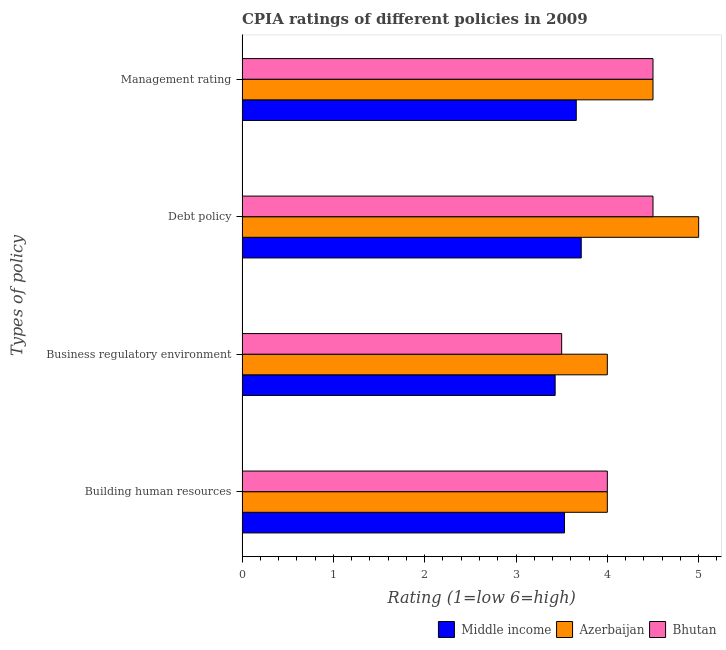How many groups of bars are there?
Give a very brief answer. 4. Are the number of bars on each tick of the Y-axis equal?
Offer a very short reply. Yes. How many bars are there on the 2nd tick from the bottom?
Provide a succinct answer. 3. What is the label of the 2nd group of bars from the top?
Provide a short and direct response. Debt policy. What is the cpia rating of management in Middle income?
Ensure brevity in your answer.  3.66. Across all countries, what is the minimum cpia rating of building human resources?
Make the answer very short. 3.53. In which country was the cpia rating of debt policy maximum?
Offer a terse response. Azerbaijan. In which country was the cpia rating of building human resources minimum?
Your answer should be very brief. Middle income. What is the total cpia rating of building human resources in the graph?
Offer a very short reply. 11.53. What is the difference between the cpia rating of debt policy in Bhutan and that in Azerbaijan?
Offer a terse response. -0.5. What is the difference between the cpia rating of management in Azerbaijan and the cpia rating of building human resources in Middle income?
Keep it short and to the point. 0.97. What is the average cpia rating of debt policy per country?
Provide a short and direct response. 4.4. What is the difference between the cpia rating of business regulatory environment and cpia rating of building human resources in Middle income?
Your answer should be compact. -0.1. What is the ratio of the cpia rating of debt policy in Bhutan to that in Middle income?
Give a very brief answer. 1.21. Is the cpia rating of debt policy in Middle income less than that in Azerbaijan?
Make the answer very short. Yes. What is the difference between the highest and the lowest cpia rating of debt policy?
Your answer should be compact. 1.29. In how many countries, is the cpia rating of management greater than the average cpia rating of management taken over all countries?
Your response must be concise. 2. Is the sum of the cpia rating of building human resources in Middle income and Azerbaijan greater than the maximum cpia rating of debt policy across all countries?
Make the answer very short. Yes. Is it the case that in every country, the sum of the cpia rating of building human resources and cpia rating of management is greater than the sum of cpia rating of debt policy and cpia rating of business regulatory environment?
Ensure brevity in your answer.  No. What does the 3rd bar from the bottom in Building human resources represents?
Keep it short and to the point. Bhutan. Is it the case that in every country, the sum of the cpia rating of building human resources and cpia rating of business regulatory environment is greater than the cpia rating of debt policy?
Your answer should be very brief. Yes. How many bars are there?
Offer a very short reply. 12. How many countries are there in the graph?
Provide a short and direct response. 3. What is the difference between two consecutive major ticks on the X-axis?
Give a very brief answer. 1. Are the values on the major ticks of X-axis written in scientific E-notation?
Your response must be concise. No. Does the graph contain any zero values?
Your response must be concise. No. Does the graph contain grids?
Offer a terse response. No. How are the legend labels stacked?
Your answer should be compact. Horizontal. What is the title of the graph?
Provide a succinct answer. CPIA ratings of different policies in 2009. Does "Oman" appear as one of the legend labels in the graph?
Provide a succinct answer. No. What is the label or title of the Y-axis?
Ensure brevity in your answer.  Types of policy. What is the Rating (1=low 6=high) in Middle income in Building human resources?
Provide a short and direct response. 3.53. What is the Rating (1=low 6=high) of Bhutan in Building human resources?
Ensure brevity in your answer.  4. What is the Rating (1=low 6=high) of Middle income in Business regulatory environment?
Keep it short and to the point. 3.43. What is the Rating (1=low 6=high) of Middle income in Debt policy?
Make the answer very short. 3.71. What is the Rating (1=low 6=high) in Azerbaijan in Debt policy?
Your answer should be very brief. 5. What is the Rating (1=low 6=high) in Bhutan in Debt policy?
Give a very brief answer. 4.5. What is the Rating (1=low 6=high) of Middle income in Management rating?
Make the answer very short. 3.66. What is the Rating (1=low 6=high) of Azerbaijan in Management rating?
Offer a very short reply. 4.5. Across all Types of policy, what is the maximum Rating (1=low 6=high) in Middle income?
Offer a very short reply. 3.71. Across all Types of policy, what is the maximum Rating (1=low 6=high) of Azerbaijan?
Make the answer very short. 5. Across all Types of policy, what is the minimum Rating (1=low 6=high) of Middle income?
Keep it short and to the point. 3.43. What is the total Rating (1=low 6=high) of Middle income in the graph?
Your response must be concise. 14.33. What is the total Rating (1=low 6=high) of Azerbaijan in the graph?
Make the answer very short. 17.5. What is the total Rating (1=low 6=high) in Bhutan in the graph?
Ensure brevity in your answer.  16.5. What is the difference between the Rating (1=low 6=high) of Middle income in Building human resources and that in Business regulatory environment?
Ensure brevity in your answer.  0.1. What is the difference between the Rating (1=low 6=high) in Bhutan in Building human resources and that in Business regulatory environment?
Your answer should be very brief. 0.5. What is the difference between the Rating (1=low 6=high) of Middle income in Building human resources and that in Debt policy?
Offer a terse response. -0.18. What is the difference between the Rating (1=low 6=high) in Azerbaijan in Building human resources and that in Debt policy?
Provide a succinct answer. -1. What is the difference between the Rating (1=low 6=high) in Bhutan in Building human resources and that in Debt policy?
Make the answer very short. -0.5. What is the difference between the Rating (1=low 6=high) of Middle income in Building human resources and that in Management rating?
Provide a short and direct response. -0.13. What is the difference between the Rating (1=low 6=high) in Middle income in Business regulatory environment and that in Debt policy?
Make the answer very short. -0.29. What is the difference between the Rating (1=low 6=high) of Azerbaijan in Business regulatory environment and that in Debt policy?
Keep it short and to the point. -1. What is the difference between the Rating (1=low 6=high) of Middle income in Business regulatory environment and that in Management rating?
Ensure brevity in your answer.  -0.23. What is the difference between the Rating (1=low 6=high) of Azerbaijan in Business regulatory environment and that in Management rating?
Keep it short and to the point. -0.5. What is the difference between the Rating (1=low 6=high) of Middle income in Debt policy and that in Management rating?
Your answer should be very brief. 0.05. What is the difference between the Rating (1=low 6=high) of Middle income in Building human resources and the Rating (1=low 6=high) of Azerbaijan in Business regulatory environment?
Make the answer very short. -0.47. What is the difference between the Rating (1=low 6=high) in Middle income in Building human resources and the Rating (1=low 6=high) in Bhutan in Business regulatory environment?
Ensure brevity in your answer.  0.03. What is the difference between the Rating (1=low 6=high) in Azerbaijan in Building human resources and the Rating (1=low 6=high) in Bhutan in Business regulatory environment?
Provide a succinct answer. 0.5. What is the difference between the Rating (1=low 6=high) of Middle income in Building human resources and the Rating (1=low 6=high) of Azerbaijan in Debt policy?
Your answer should be very brief. -1.47. What is the difference between the Rating (1=low 6=high) of Middle income in Building human resources and the Rating (1=low 6=high) of Bhutan in Debt policy?
Keep it short and to the point. -0.97. What is the difference between the Rating (1=low 6=high) in Middle income in Building human resources and the Rating (1=low 6=high) in Azerbaijan in Management rating?
Give a very brief answer. -0.97. What is the difference between the Rating (1=low 6=high) in Middle income in Building human resources and the Rating (1=low 6=high) in Bhutan in Management rating?
Give a very brief answer. -0.97. What is the difference between the Rating (1=low 6=high) in Middle income in Business regulatory environment and the Rating (1=low 6=high) in Azerbaijan in Debt policy?
Provide a short and direct response. -1.57. What is the difference between the Rating (1=low 6=high) in Middle income in Business regulatory environment and the Rating (1=low 6=high) in Bhutan in Debt policy?
Give a very brief answer. -1.07. What is the difference between the Rating (1=low 6=high) of Middle income in Business regulatory environment and the Rating (1=low 6=high) of Azerbaijan in Management rating?
Provide a succinct answer. -1.07. What is the difference between the Rating (1=low 6=high) of Middle income in Business regulatory environment and the Rating (1=low 6=high) of Bhutan in Management rating?
Ensure brevity in your answer.  -1.07. What is the difference between the Rating (1=low 6=high) in Azerbaijan in Business regulatory environment and the Rating (1=low 6=high) in Bhutan in Management rating?
Give a very brief answer. -0.5. What is the difference between the Rating (1=low 6=high) in Middle income in Debt policy and the Rating (1=low 6=high) in Azerbaijan in Management rating?
Make the answer very short. -0.79. What is the difference between the Rating (1=low 6=high) of Middle income in Debt policy and the Rating (1=low 6=high) of Bhutan in Management rating?
Make the answer very short. -0.79. What is the average Rating (1=low 6=high) of Middle income per Types of policy?
Provide a short and direct response. 3.58. What is the average Rating (1=low 6=high) of Azerbaijan per Types of policy?
Give a very brief answer. 4.38. What is the average Rating (1=low 6=high) of Bhutan per Types of policy?
Offer a terse response. 4.12. What is the difference between the Rating (1=low 6=high) of Middle income and Rating (1=low 6=high) of Azerbaijan in Building human resources?
Your answer should be very brief. -0.47. What is the difference between the Rating (1=low 6=high) of Middle income and Rating (1=low 6=high) of Bhutan in Building human resources?
Your response must be concise. -0.47. What is the difference between the Rating (1=low 6=high) of Azerbaijan and Rating (1=low 6=high) of Bhutan in Building human resources?
Provide a succinct answer. 0. What is the difference between the Rating (1=low 6=high) in Middle income and Rating (1=low 6=high) in Azerbaijan in Business regulatory environment?
Your answer should be very brief. -0.57. What is the difference between the Rating (1=low 6=high) of Middle income and Rating (1=low 6=high) of Bhutan in Business regulatory environment?
Your answer should be compact. -0.07. What is the difference between the Rating (1=low 6=high) in Middle income and Rating (1=low 6=high) in Azerbaijan in Debt policy?
Offer a very short reply. -1.29. What is the difference between the Rating (1=low 6=high) in Middle income and Rating (1=low 6=high) in Bhutan in Debt policy?
Your answer should be compact. -0.79. What is the difference between the Rating (1=low 6=high) of Azerbaijan and Rating (1=low 6=high) of Bhutan in Debt policy?
Your answer should be compact. 0.5. What is the difference between the Rating (1=low 6=high) in Middle income and Rating (1=low 6=high) in Azerbaijan in Management rating?
Ensure brevity in your answer.  -0.84. What is the difference between the Rating (1=low 6=high) of Middle income and Rating (1=low 6=high) of Bhutan in Management rating?
Give a very brief answer. -0.84. What is the difference between the Rating (1=low 6=high) of Azerbaijan and Rating (1=low 6=high) of Bhutan in Management rating?
Your answer should be compact. 0. What is the ratio of the Rating (1=low 6=high) in Middle income in Building human resources to that in Business regulatory environment?
Your answer should be very brief. 1.03. What is the ratio of the Rating (1=low 6=high) in Middle income in Building human resources to that in Debt policy?
Offer a very short reply. 0.95. What is the ratio of the Rating (1=low 6=high) in Azerbaijan in Building human resources to that in Debt policy?
Give a very brief answer. 0.8. What is the ratio of the Rating (1=low 6=high) of Middle income in Building human resources to that in Management rating?
Provide a short and direct response. 0.96. What is the ratio of the Rating (1=low 6=high) of Bhutan in Building human resources to that in Management rating?
Ensure brevity in your answer.  0.89. What is the ratio of the Rating (1=low 6=high) of Middle income in Business regulatory environment to that in Debt policy?
Provide a succinct answer. 0.92. What is the ratio of the Rating (1=low 6=high) of Azerbaijan in Business regulatory environment to that in Debt policy?
Your answer should be very brief. 0.8. What is the ratio of the Rating (1=low 6=high) of Middle income in Business regulatory environment to that in Management rating?
Your answer should be very brief. 0.94. What is the ratio of the Rating (1=low 6=high) in Azerbaijan in Business regulatory environment to that in Management rating?
Offer a terse response. 0.89. What is the ratio of the Rating (1=low 6=high) in Middle income in Debt policy to that in Management rating?
Your response must be concise. 1.01. What is the ratio of the Rating (1=low 6=high) in Bhutan in Debt policy to that in Management rating?
Give a very brief answer. 1. What is the difference between the highest and the second highest Rating (1=low 6=high) in Middle income?
Give a very brief answer. 0.05. What is the difference between the highest and the second highest Rating (1=low 6=high) of Azerbaijan?
Make the answer very short. 0.5. What is the difference between the highest and the second highest Rating (1=low 6=high) in Bhutan?
Offer a very short reply. 0. What is the difference between the highest and the lowest Rating (1=low 6=high) in Middle income?
Provide a succinct answer. 0.29. 